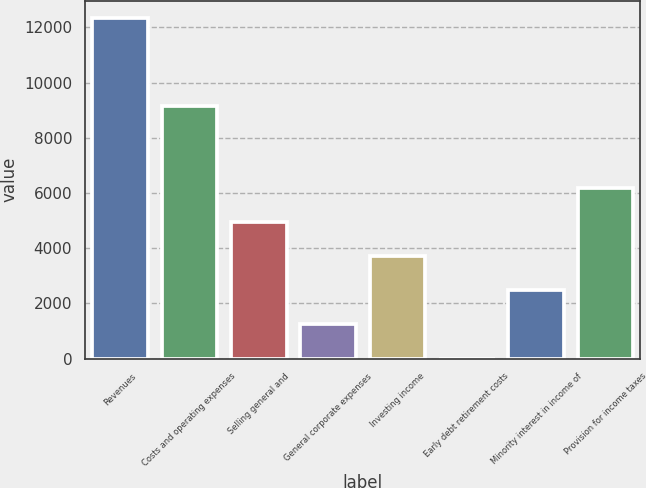<chart> <loc_0><loc_0><loc_500><loc_500><bar_chart><fcel>Revenues<fcel>Costs and operating expenses<fcel>Selling general and<fcel>General corporate expenses<fcel>Investing income<fcel>Early debt retirement costs<fcel>Minority interest in income of<fcel>Provision for income taxes<nl><fcel>12352<fcel>9156<fcel>4941.4<fcel>1236.1<fcel>3706.3<fcel>1<fcel>2471.2<fcel>6176.5<nl></chart> 